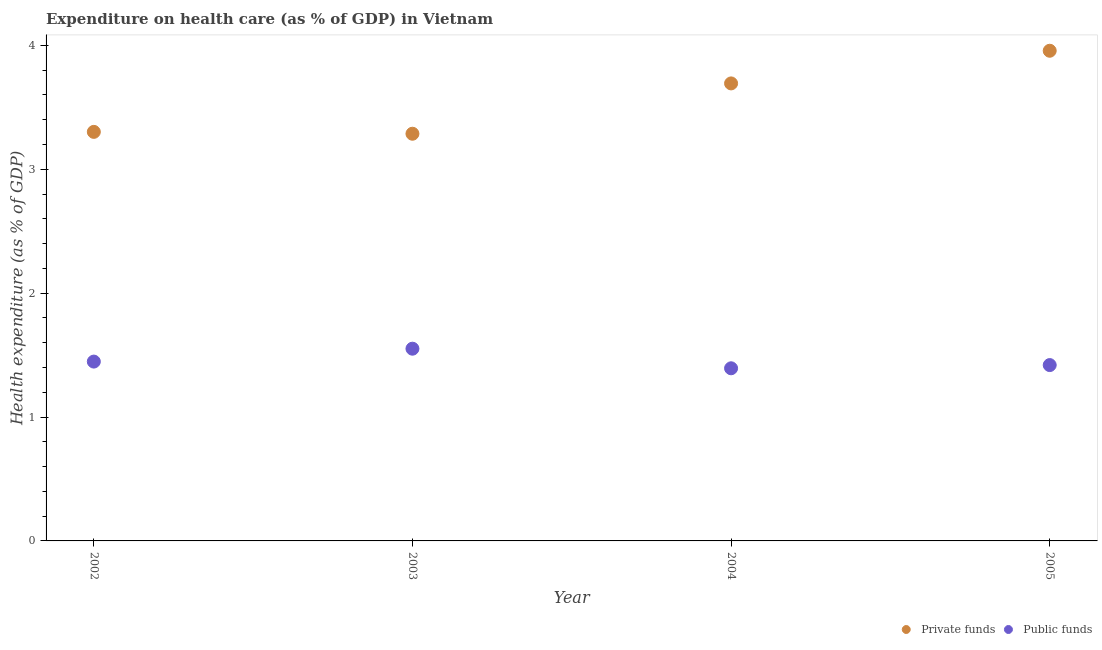Is the number of dotlines equal to the number of legend labels?
Make the answer very short. Yes. What is the amount of private funds spent in healthcare in 2002?
Provide a short and direct response. 3.3. Across all years, what is the maximum amount of private funds spent in healthcare?
Provide a succinct answer. 3.96. Across all years, what is the minimum amount of public funds spent in healthcare?
Your answer should be very brief. 1.39. In which year was the amount of private funds spent in healthcare maximum?
Make the answer very short. 2005. In which year was the amount of public funds spent in healthcare minimum?
Keep it short and to the point. 2004. What is the total amount of private funds spent in healthcare in the graph?
Offer a terse response. 14.24. What is the difference between the amount of public funds spent in healthcare in 2002 and that in 2005?
Offer a very short reply. 0.03. What is the difference between the amount of private funds spent in healthcare in 2003 and the amount of public funds spent in healthcare in 2005?
Your answer should be compact. 1.87. What is the average amount of public funds spent in healthcare per year?
Your response must be concise. 1.45. In the year 2002, what is the difference between the amount of private funds spent in healthcare and amount of public funds spent in healthcare?
Offer a terse response. 1.85. What is the ratio of the amount of public funds spent in healthcare in 2002 to that in 2003?
Keep it short and to the point. 0.93. What is the difference between the highest and the second highest amount of private funds spent in healthcare?
Keep it short and to the point. 0.26. What is the difference between the highest and the lowest amount of private funds spent in healthcare?
Offer a terse response. 0.67. In how many years, is the amount of public funds spent in healthcare greater than the average amount of public funds spent in healthcare taken over all years?
Give a very brief answer. 1. Is the sum of the amount of public funds spent in healthcare in 2002 and 2003 greater than the maximum amount of private funds spent in healthcare across all years?
Give a very brief answer. No. Does the amount of public funds spent in healthcare monotonically increase over the years?
Provide a short and direct response. No. Is the amount of public funds spent in healthcare strictly less than the amount of private funds spent in healthcare over the years?
Your answer should be compact. Yes. How many dotlines are there?
Make the answer very short. 2. How many years are there in the graph?
Offer a terse response. 4. Where does the legend appear in the graph?
Ensure brevity in your answer.  Bottom right. How many legend labels are there?
Your answer should be very brief. 2. How are the legend labels stacked?
Offer a very short reply. Horizontal. What is the title of the graph?
Offer a terse response. Expenditure on health care (as % of GDP) in Vietnam. What is the label or title of the X-axis?
Your response must be concise. Year. What is the label or title of the Y-axis?
Offer a very short reply. Health expenditure (as % of GDP). What is the Health expenditure (as % of GDP) of Private funds in 2002?
Your answer should be compact. 3.3. What is the Health expenditure (as % of GDP) in Public funds in 2002?
Give a very brief answer. 1.45. What is the Health expenditure (as % of GDP) in Private funds in 2003?
Give a very brief answer. 3.29. What is the Health expenditure (as % of GDP) of Public funds in 2003?
Provide a succinct answer. 1.55. What is the Health expenditure (as % of GDP) of Private funds in 2004?
Keep it short and to the point. 3.69. What is the Health expenditure (as % of GDP) in Public funds in 2004?
Ensure brevity in your answer.  1.39. What is the Health expenditure (as % of GDP) of Private funds in 2005?
Your answer should be compact. 3.96. What is the Health expenditure (as % of GDP) in Public funds in 2005?
Your answer should be compact. 1.42. Across all years, what is the maximum Health expenditure (as % of GDP) in Private funds?
Provide a succinct answer. 3.96. Across all years, what is the maximum Health expenditure (as % of GDP) of Public funds?
Make the answer very short. 1.55. Across all years, what is the minimum Health expenditure (as % of GDP) in Private funds?
Your answer should be compact. 3.29. Across all years, what is the minimum Health expenditure (as % of GDP) in Public funds?
Your response must be concise. 1.39. What is the total Health expenditure (as % of GDP) of Private funds in the graph?
Your answer should be very brief. 14.24. What is the total Health expenditure (as % of GDP) in Public funds in the graph?
Provide a short and direct response. 5.81. What is the difference between the Health expenditure (as % of GDP) in Private funds in 2002 and that in 2003?
Offer a terse response. 0.01. What is the difference between the Health expenditure (as % of GDP) in Public funds in 2002 and that in 2003?
Offer a terse response. -0.1. What is the difference between the Health expenditure (as % of GDP) in Private funds in 2002 and that in 2004?
Your answer should be compact. -0.39. What is the difference between the Health expenditure (as % of GDP) in Public funds in 2002 and that in 2004?
Your response must be concise. 0.05. What is the difference between the Health expenditure (as % of GDP) in Private funds in 2002 and that in 2005?
Your response must be concise. -0.65. What is the difference between the Health expenditure (as % of GDP) in Public funds in 2002 and that in 2005?
Your answer should be compact. 0.03. What is the difference between the Health expenditure (as % of GDP) in Private funds in 2003 and that in 2004?
Offer a terse response. -0.41. What is the difference between the Health expenditure (as % of GDP) in Public funds in 2003 and that in 2004?
Make the answer very short. 0.16. What is the difference between the Health expenditure (as % of GDP) in Private funds in 2003 and that in 2005?
Provide a short and direct response. -0.67. What is the difference between the Health expenditure (as % of GDP) in Public funds in 2003 and that in 2005?
Keep it short and to the point. 0.13. What is the difference between the Health expenditure (as % of GDP) in Private funds in 2004 and that in 2005?
Your answer should be very brief. -0.26. What is the difference between the Health expenditure (as % of GDP) in Public funds in 2004 and that in 2005?
Keep it short and to the point. -0.03. What is the difference between the Health expenditure (as % of GDP) in Private funds in 2002 and the Health expenditure (as % of GDP) in Public funds in 2003?
Offer a very short reply. 1.75. What is the difference between the Health expenditure (as % of GDP) in Private funds in 2002 and the Health expenditure (as % of GDP) in Public funds in 2004?
Give a very brief answer. 1.91. What is the difference between the Health expenditure (as % of GDP) of Private funds in 2002 and the Health expenditure (as % of GDP) of Public funds in 2005?
Your answer should be very brief. 1.88. What is the difference between the Health expenditure (as % of GDP) of Private funds in 2003 and the Health expenditure (as % of GDP) of Public funds in 2004?
Your answer should be compact. 1.89. What is the difference between the Health expenditure (as % of GDP) of Private funds in 2003 and the Health expenditure (as % of GDP) of Public funds in 2005?
Offer a terse response. 1.87. What is the difference between the Health expenditure (as % of GDP) in Private funds in 2004 and the Health expenditure (as % of GDP) in Public funds in 2005?
Your response must be concise. 2.27. What is the average Health expenditure (as % of GDP) in Private funds per year?
Provide a succinct answer. 3.56. What is the average Health expenditure (as % of GDP) in Public funds per year?
Keep it short and to the point. 1.45. In the year 2002, what is the difference between the Health expenditure (as % of GDP) of Private funds and Health expenditure (as % of GDP) of Public funds?
Offer a terse response. 1.85. In the year 2003, what is the difference between the Health expenditure (as % of GDP) of Private funds and Health expenditure (as % of GDP) of Public funds?
Your response must be concise. 1.74. In the year 2004, what is the difference between the Health expenditure (as % of GDP) in Private funds and Health expenditure (as % of GDP) in Public funds?
Give a very brief answer. 2.3. In the year 2005, what is the difference between the Health expenditure (as % of GDP) of Private funds and Health expenditure (as % of GDP) of Public funds?
Your response must be concise. 2.54. What is the ratio of the Health expenditure (as % of GDP) of Public funds in 2002 to that in 2003?
Give a very brief answer. 0.93. What is the ratio of the Health expenditure (as % of GDP) in Private funds in 2002 to that in 2004?
Provide a succinct answer. 0.89. What is the ratio of the Health expenditure (as % of GDP) in Public funds in 2002 to that in 2004?
Give a very brief answer. 1.04. What is the ratio of the Health expenditure (as % of GDP) of Private funds in 2002 to that in 2005?
Provide a succinct answer. 0.83. What is the ratio of the Health expenditure (as % of GDP) of Public funds in 2002 to that in 2005?
Your answer should be very brief. 1.02. What is the ratio of the Health expenditure (as % of GDP) in Private funds in 2003 to that in 2004?
Your response must be concise. 0.89. What is the ratio of the Health expenditure (as % of GDP) of Public funds in 2003 to that in 2004?
Provide a succinct answer. 1.11. What is the ratio of the Health expenditure (as % of GDP) of Private funds in 2003 to that in 2005?
Offer a very short reply. 0.83. What is the ratio of the Health expenditure (as % of GDP) of Public funds in 2003 to that in 2005?
Provide a succinct answer. 1.09. What is the ratio of the Health expenditure (as % of GDP) of Private funds in 2004 to that in 2005?
Provide a short and direct response. 0.93. What is the ratio of the Health expenditure (as % of GDP) in Public funds in 2004 to that in 2005?
Your response must be concise. 0.98. What is the difference between the highest and the second highest Health expenditure (as % of GDP) of Private funds?
Keep it short and to the point. 0.26. What is the difference between the highest and the second highest Health expenditure (as % of GDP) of Public funds?
Provide a short and direct response. 0.1. What is the difference between the highest and the lowest Health expenditure (as % of GDP) in Private funds?
Make the answer very short. 0.67. What is the difference between the highest and the lowest Health expenditure (as % of GDP) of Public funds?
Your answer should be compact. 0.16. 